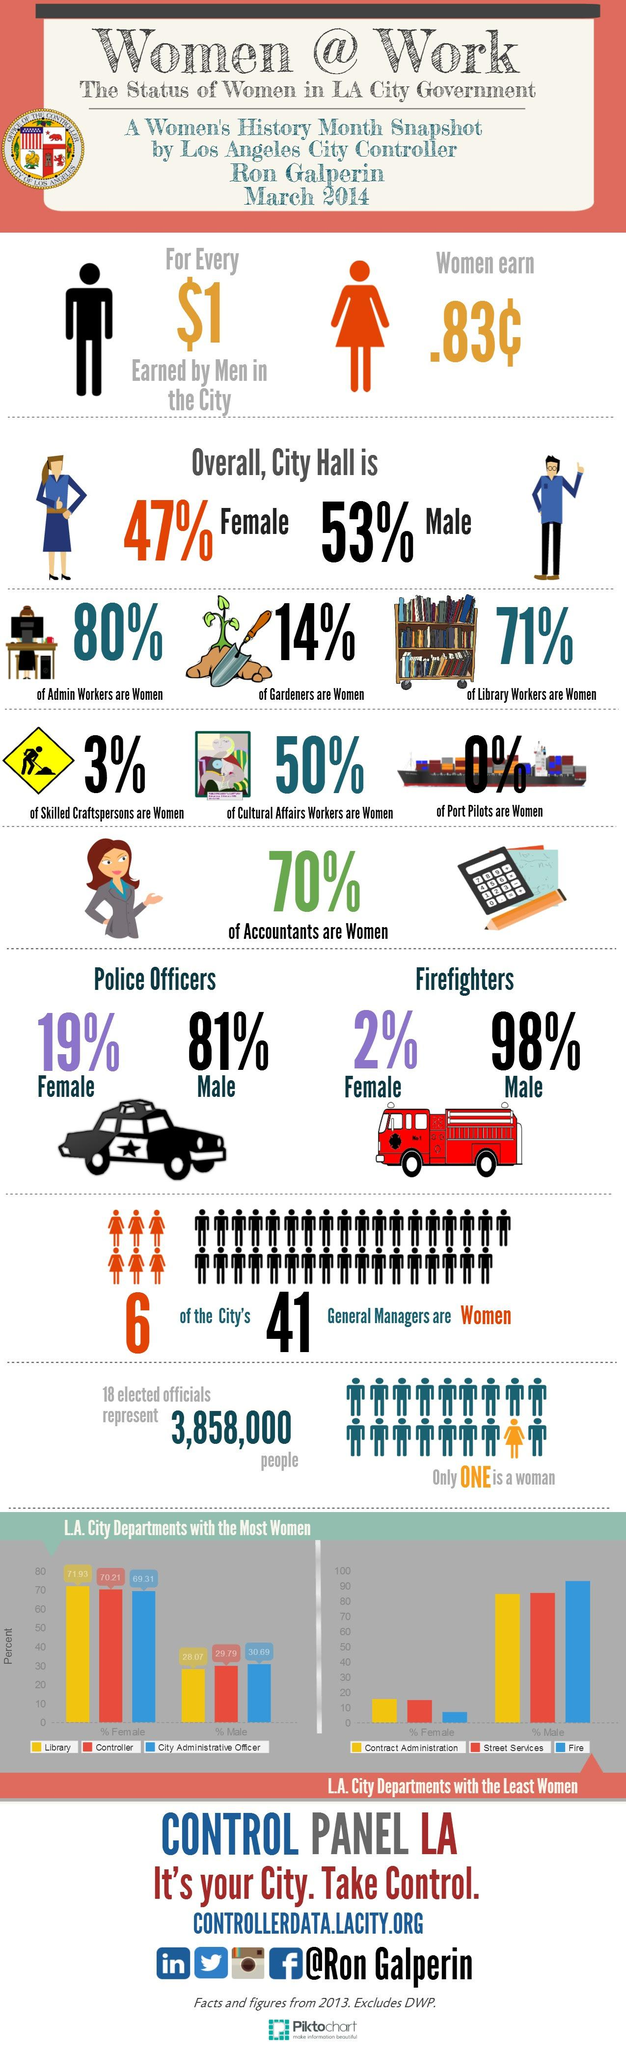Draw attention to some important aspects in this diagram. There is a significant gender gap among police officers, with 62% being male and only 38% being female. City Hall does not have the presence of women in the occupation of port pilots. It is 100% of men who are port pilots. According to the graph, 71.93% of women work in libraries. In City Hall, the gender with the larger population is male. 